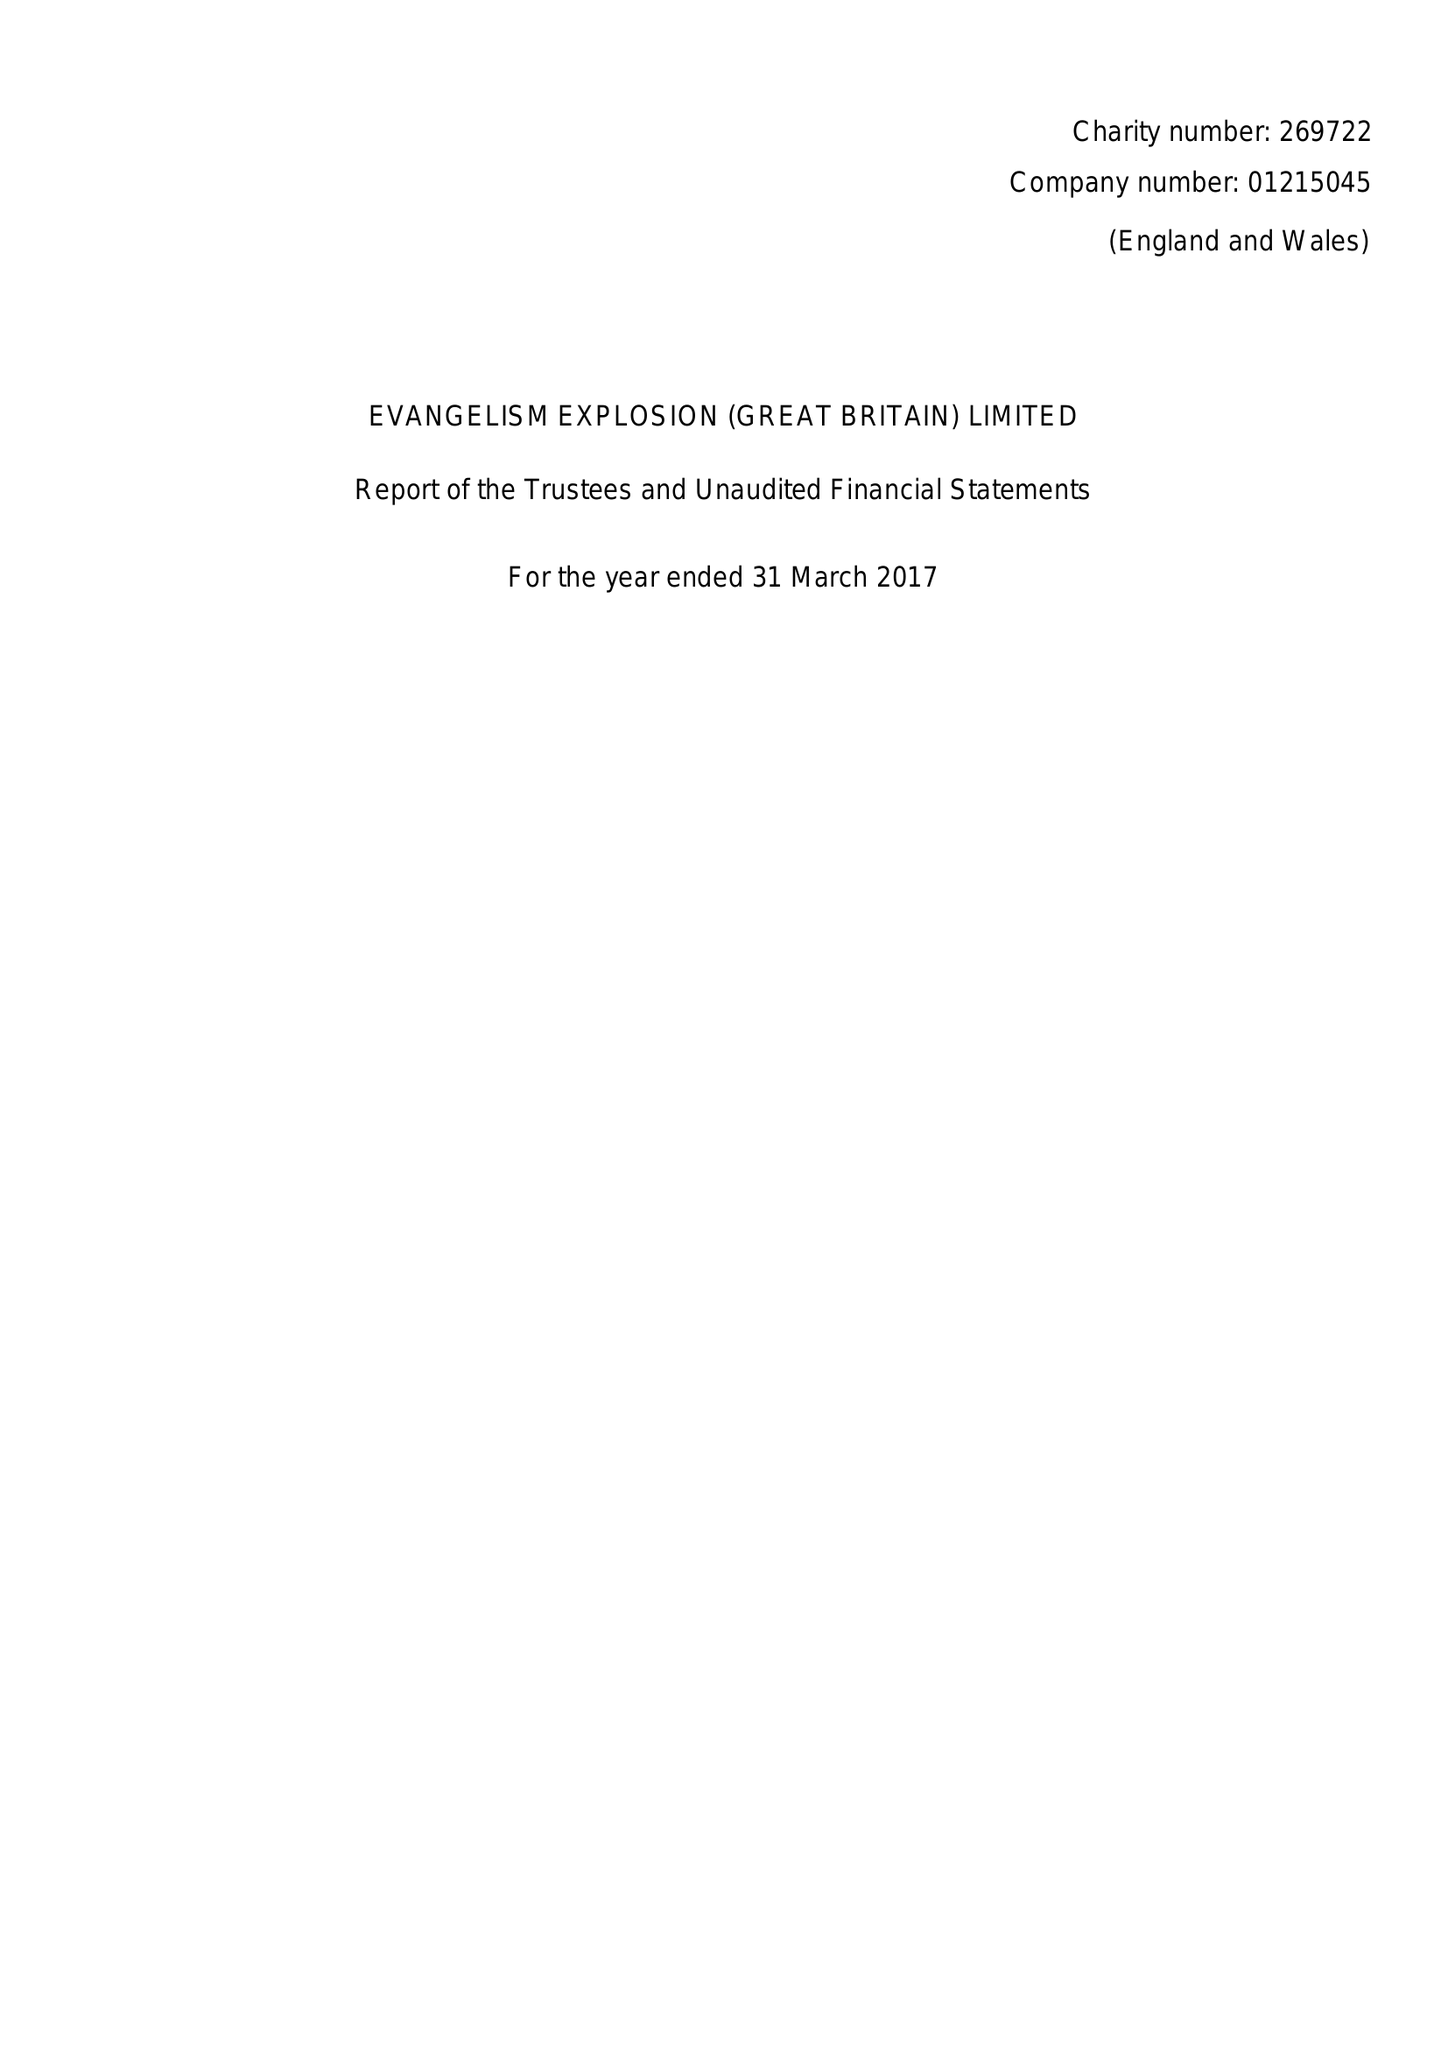What is the value for the report_date?
Answer the question using a single word or phrase. 2017-03-31 